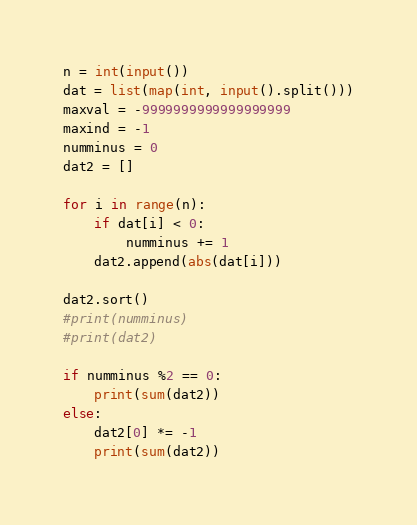<code> <loc_0><loc_0><loc_500><loc_500><_Python_>n = int(input())
dat = list(map(int, input().split()))
maxval = -9999999999999999999
maxind = -1
numminus = 0
dat2 = []

for i in range(n):
    if dat[i] < 0:
        numminus += 1
    dat2.append(abs(dat[i]))

dat2.sort()
#print(numminus)
#print(dat2)

if numminus %2 == 0:
    print(sum(dat2))
else:
    dat2[0] *= -1
    print(sum(dat2))

</code> 